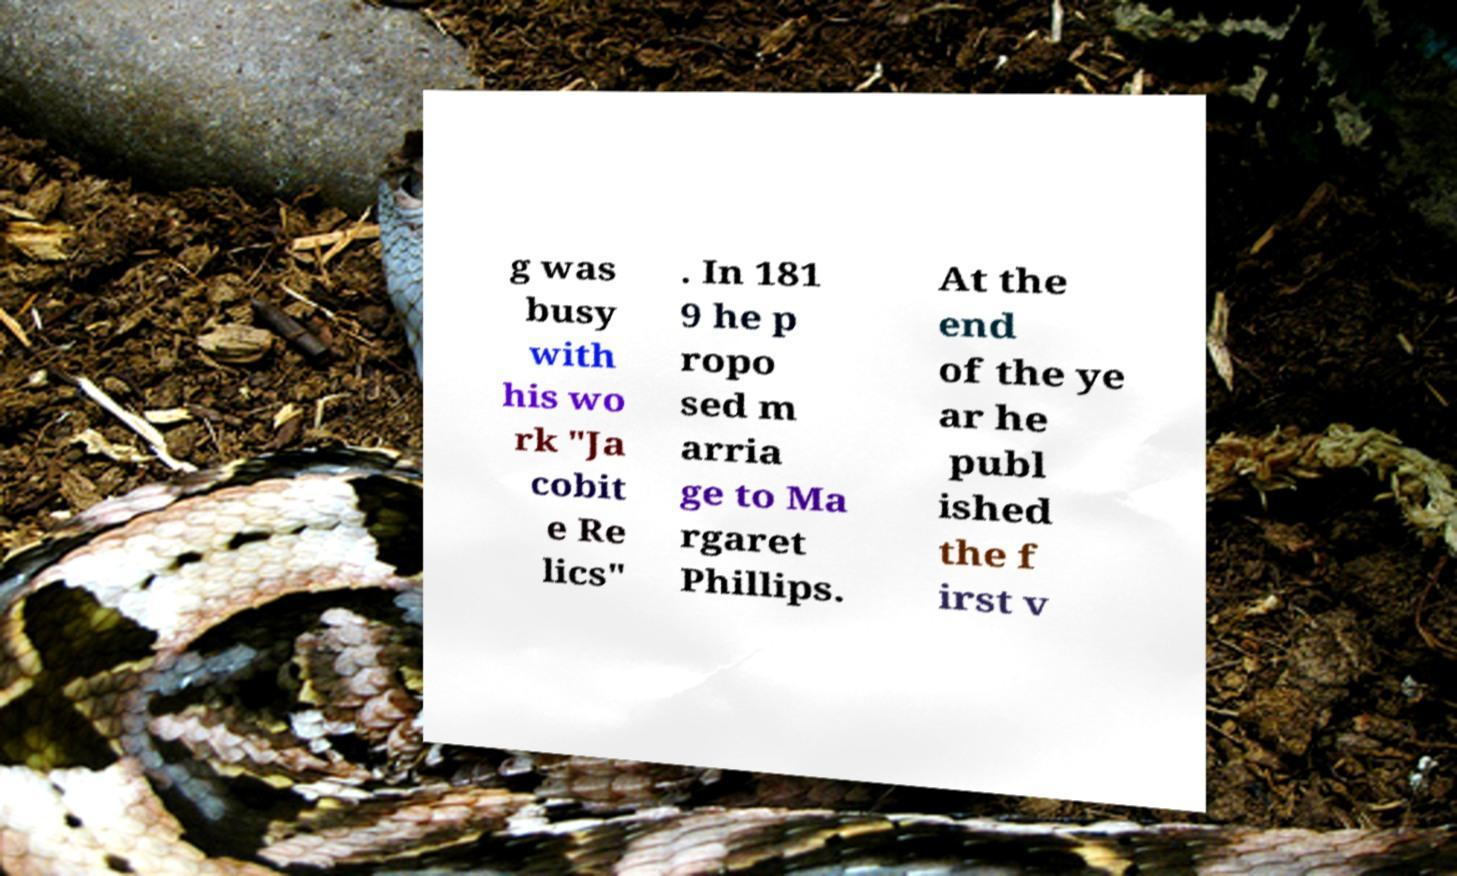There's text embedded in this image that I need extracted. Can you transcribe it verbatim? g was busy with his wo rk "Ja cobit e Re lics" . In 181 9 he p ropo sed m arria ge to Ma rgaret Phillips. At the end of the ye ar he publ ished the f irst v 